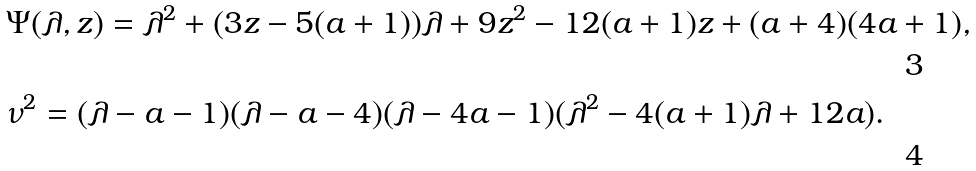<formula> <loc_0><loc_0><loc_500><loc_500>& \Psi ( \lambda , z ) = \lambda ^ { 2 } + ( 3 z - 5 ( a + 1 ) ) \lambda + 9 z ^ { 2 } - 1 2 ( a + 1 ) z + ( a + 4 ) ( 4 a + 1 ) , \\ & \nu ^ { 2 } = ( \lambda - a - 1 ) ( \lambda - a - 4 ) ( \lambda - 4 a - 1 ) ( \lambda ^ { 2 } - 4 ( a + 1 ) \lambda + 1 2 a ) .</formula> 